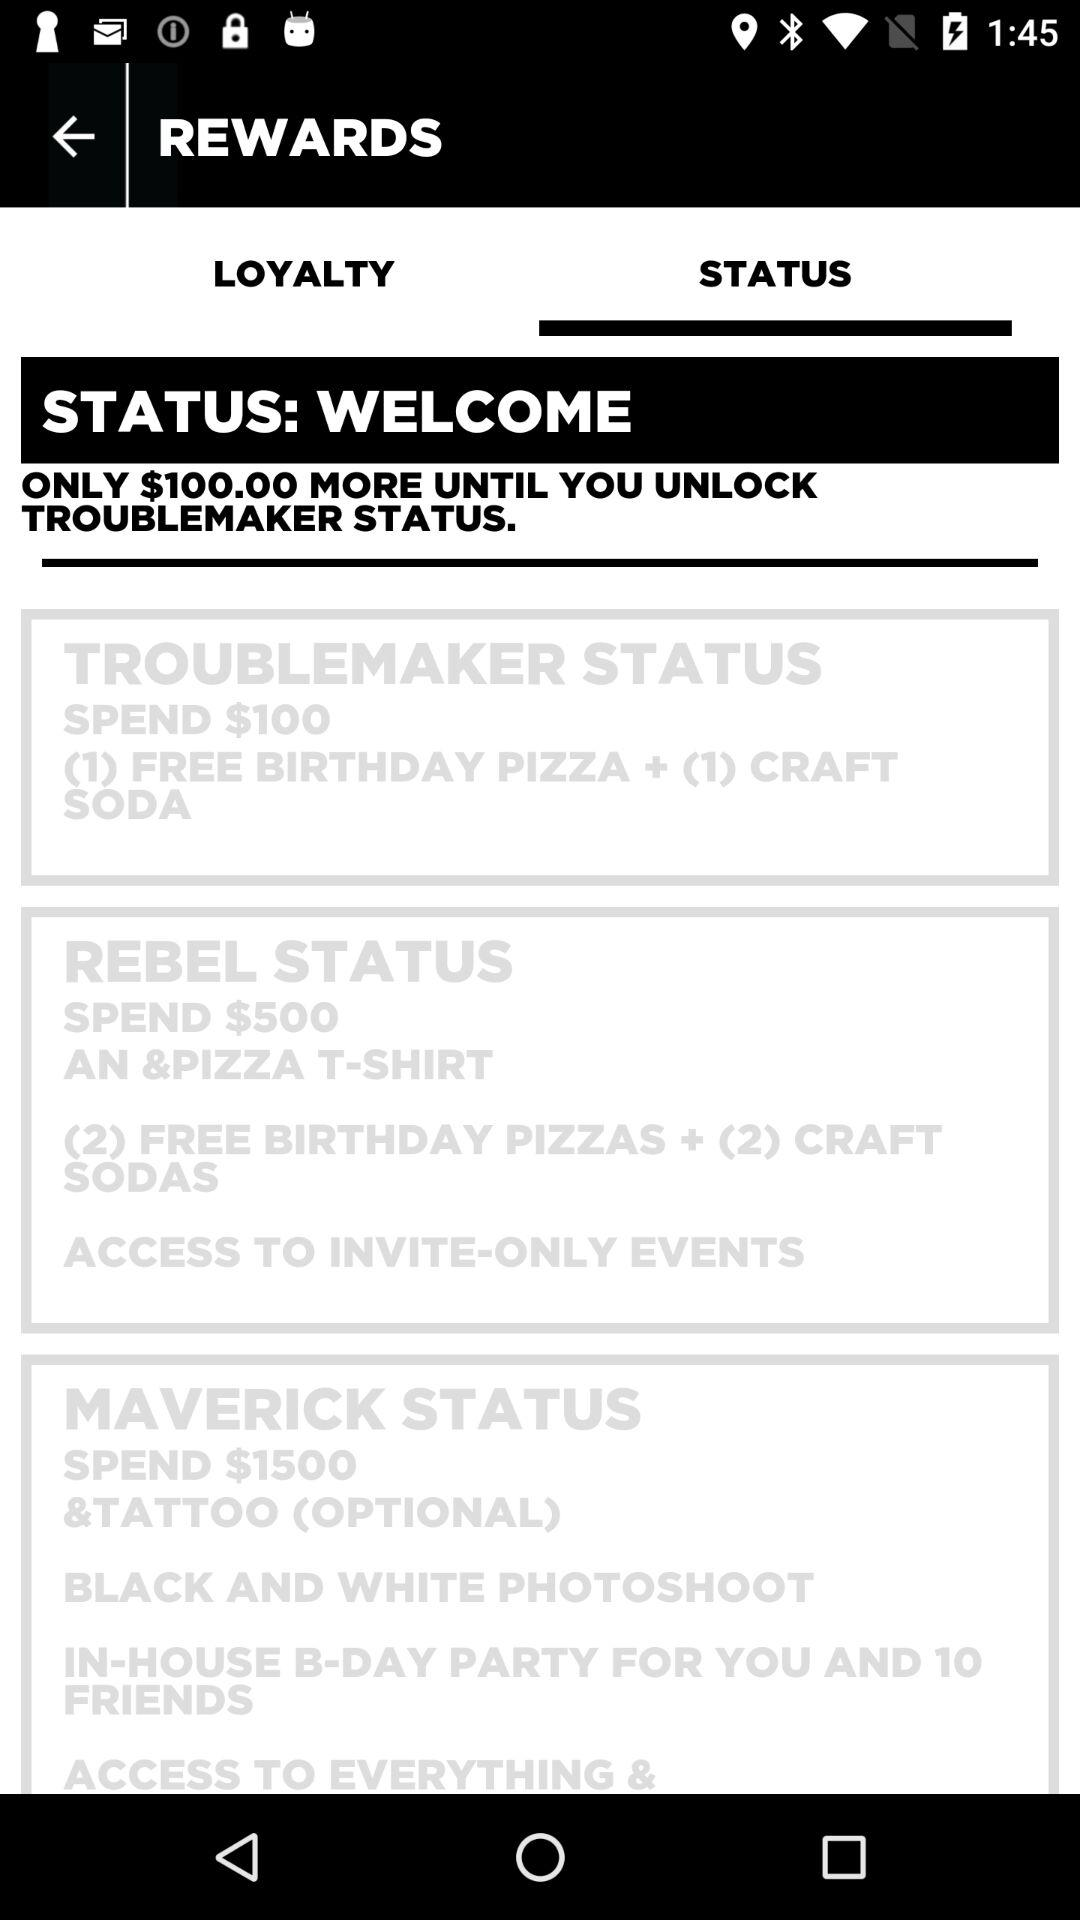Which tab is selected? The selected tab is "STATUS". 